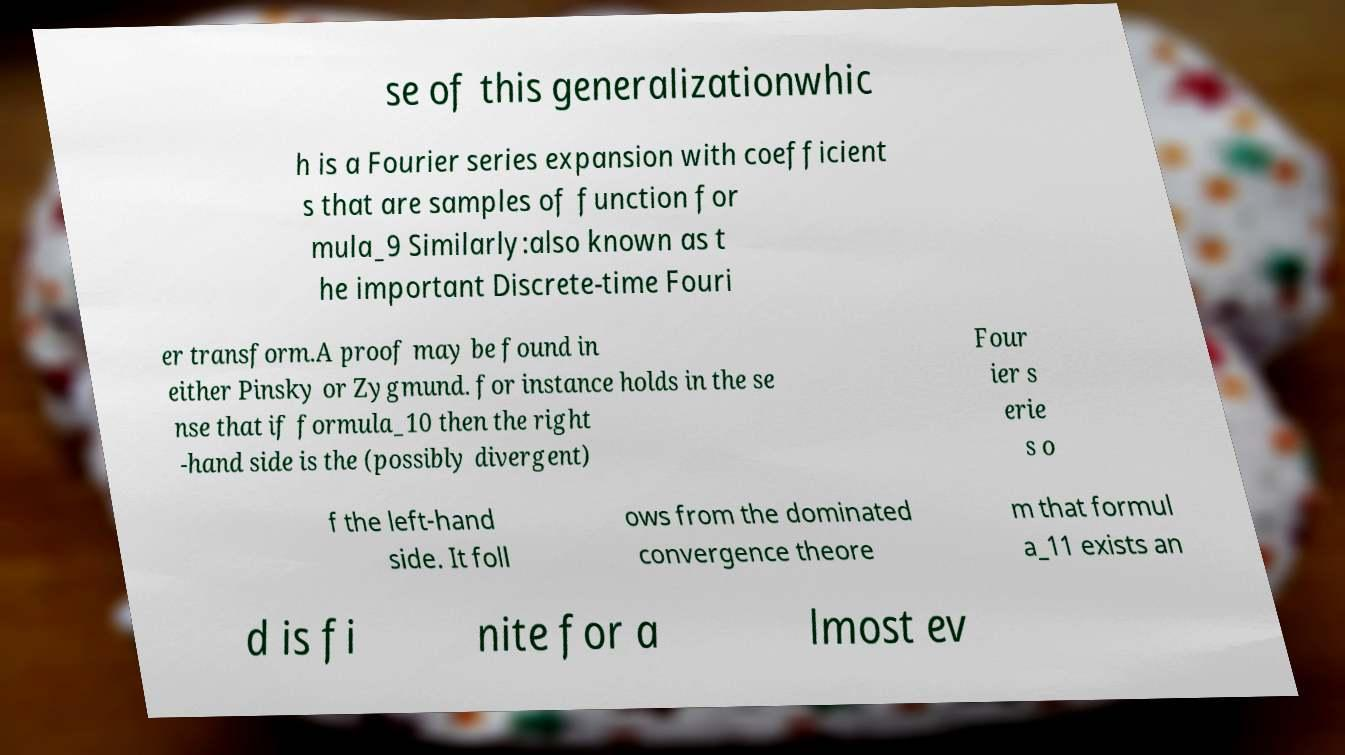What messages or text are displayed in this image? I need them in a readable, typed format. se of this generalizationwhic h is a Fourier series expansion with coefficient s that are samples of function for mula_9 Similarly:also known as t he important Discrete-time Fouri er transform.A proof may be found in either Pinsky or Zygmund. for instance holds in the se nse that if formula_10 then the right -hand side is the (possibly divergent) Four ier s erie s o f the left-hand side. It foll ows from the dominated convergence theore m that formul a_11 exists an d is fi nite for a lmost ev 